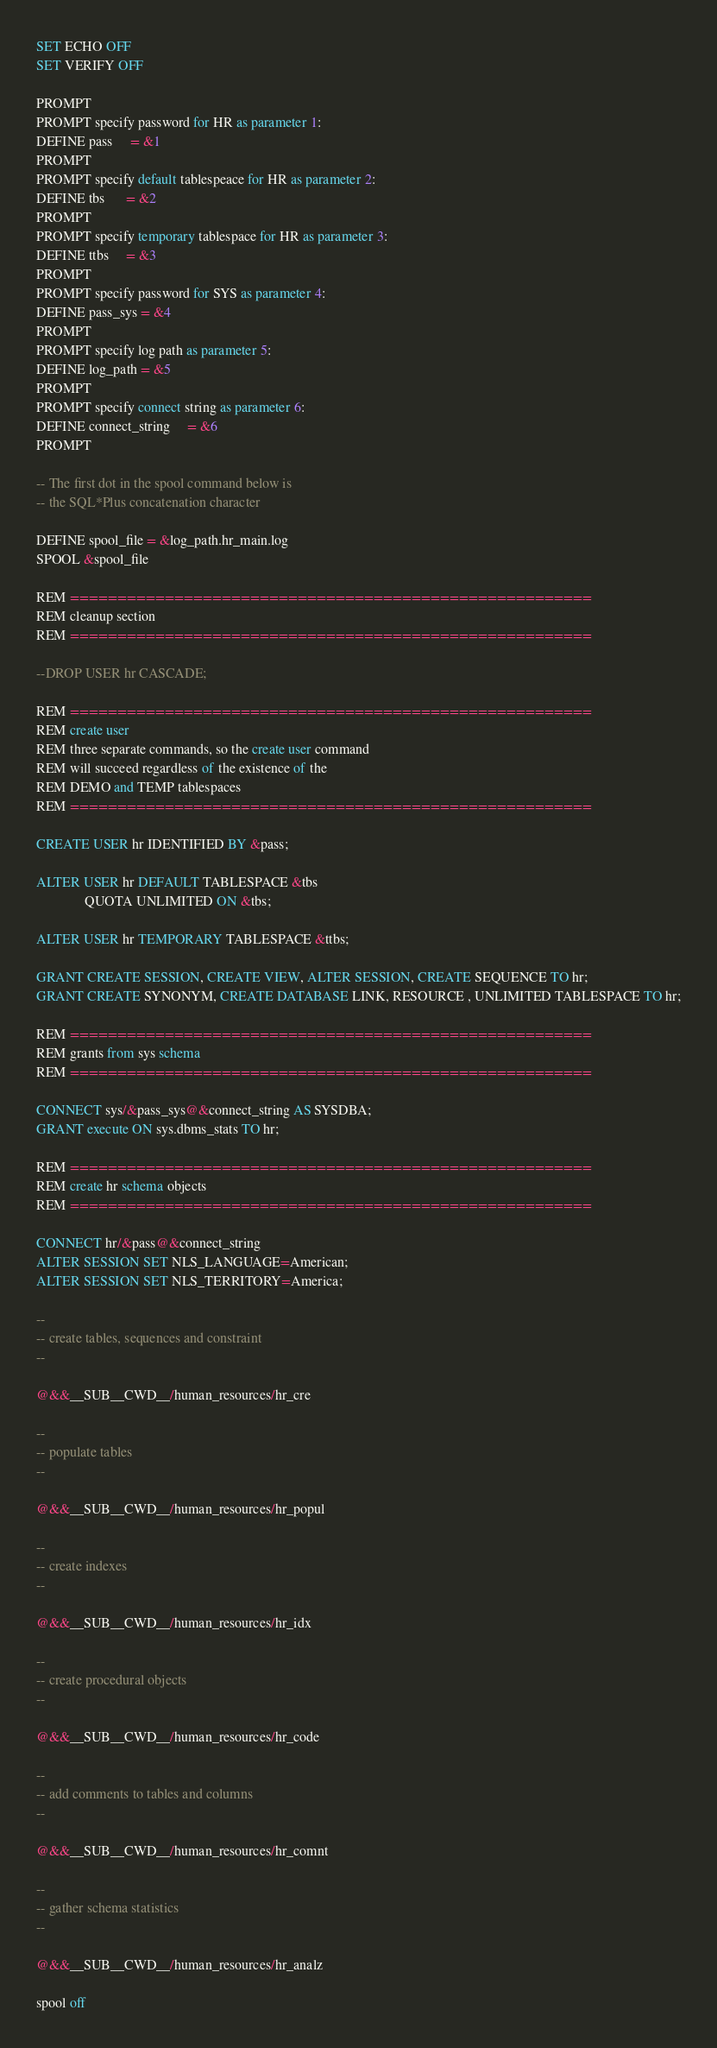Convert code to text. <code><loc_0><loc_0><loc_500><loc_500><_SQL_>
SET ECHO OFF
SET VERIFY OFF

PROMPT 
PROMPT specify password for HR as parameter 1:
DEFINE pass     = &1
PROMPT 
PROMPT specify default tablespeace for HR as parameter 2:
DEFINE tbs      = &2
PROMPT 
PROMPT specify temporary tablespace for HR as parameter 3:
DEFINE ttbs     = &3
PROMPT 
PROMPT specify password for SYS as parameter 4:
DEFINE pass_sys = &4
PROMPT 
PROMPT specify log path as parameter 5:
DEFINE log_path = &5
PROMPT
PROMPT specify connect string as parameter 6:
DEFINE connect_string     = &6
PROMPT

-- The first dot in the spool command below is 
-- the SQL*Plus concatenation character

DEFINE spool_file = &log_path.hr_main.log
SPOOL &spool_file

REM =======================================================
REM cleanup section
REM =======================================================

--DROP USER hr CASCADE;

REM =======================================================
REM create user
REM three separate commands, so the create user command 
REM will succeed regardless of the existence of the 
REM DEMO and TEMP tablespaces 
REM =======================================================

CREATE USER hr IDENTIFIED BY &pass;

ALTER USER hr DEFAULT TABLESPACE &tbs
              QUOTA UNLIMITED ON &tbs;

ALTER USER hr TEMPORARY TABLESPACE &ttbs;

GRANT CREATE SESSION, CREATE VIEW, ALTER SESSION, CREATE SEQUENCE TO hr;
GRANT CREATE SYNONYM, CREATE DATABASE LINK, RESOURCE , UNLIMITED TABLESPACE TO hr;

REM =======================================================
REM grants from sys schema
REM =======================================================

CONNECT sys/&pass_sys@&connect_string AS SYSDBA;
GRANT execute ON sys.dbms_stats TO hr;

REM =======================================================
REM create hr schema objects
REM =======================================================

CONNECT hr/&pass@&connect_string
ALTER SESSION SET NLS_LANGUAGE=American;
ALTER SESSION SET NLS_TERRITORY=America;

--
-- create tables, sequences and constraint
--

@&&__SUB__CWD__/human_resources/hr_cre

-- 
-- populate tables
--

@&&__SUB__CWD__/human_resources/hr_popul

--
-- create indexes
--

@&&__SUB__CWD__/human_resources/hr_idx

--
-- create procedural objects
--

@&&__SUB__CWD__/human_resources/hr_code

--
-- add comments to tables and columns
--

@&&__SUB__CWD__/human_resources/hr_comnt

--
-- gather schema statistics
--

@&&__SUB__CWD__/human_resources/hr_analz

spool off
</code> 